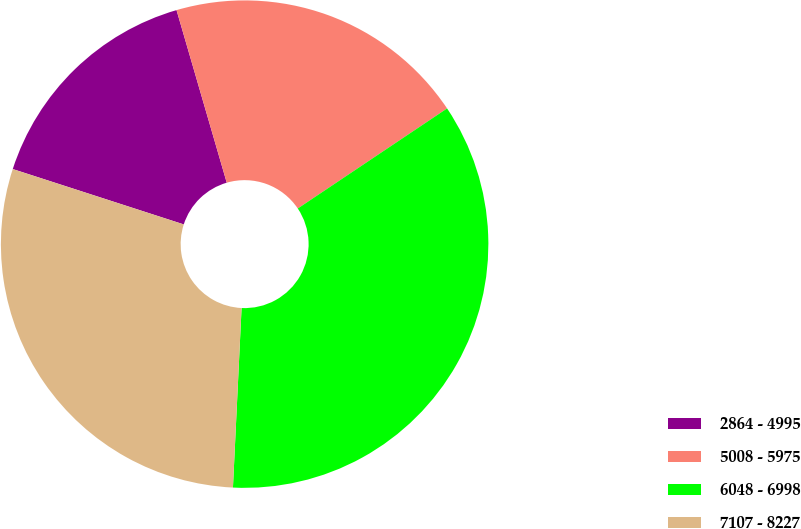Convert chart to OTSL. <chart><loc_0><loc_0><loc_500><loc_500><pie_chart><fcel>2864 - 4995<fcel>5008 - 5975<fcel>6048 - 6998<fcel>7107 - 8227<nl><fcel>15.51%<fcel>20.11%<fcel>35.16%<fcel>29.22%<nl></chart> 